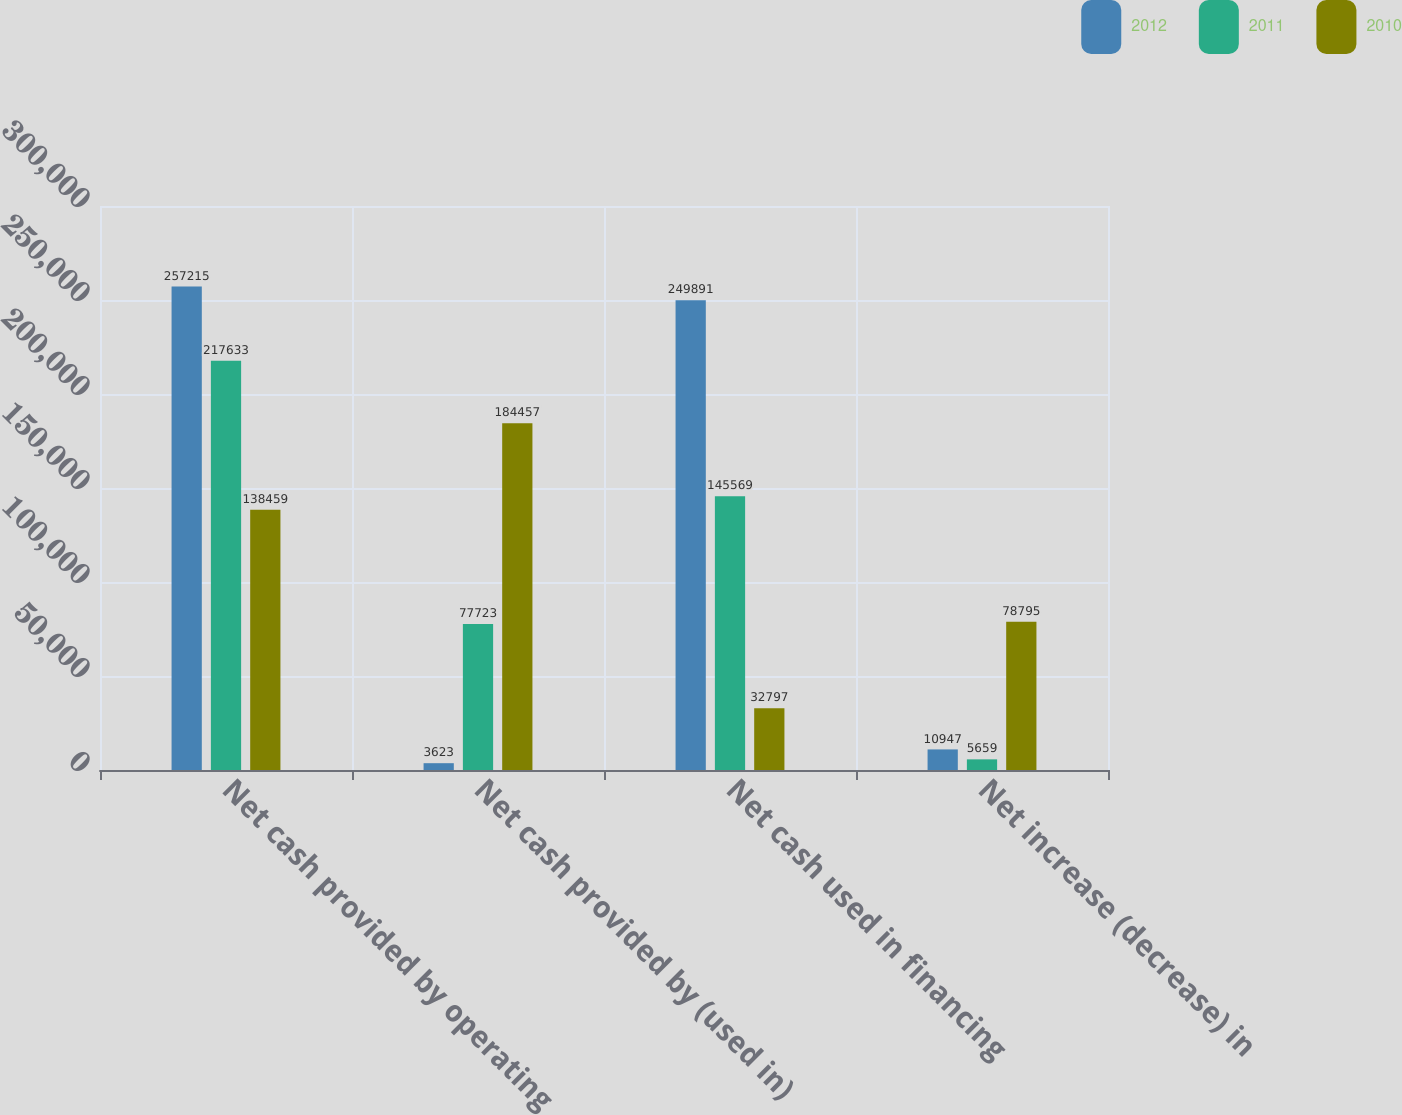Convert chart. <chart><loc_0><loc_0><loc_500><loc_500><stacked_bar_chart><ecel><fcel>Net cash provided by operating<fcel>Net cash provided by (used in)<fcel>Net cash used in financing<fcel>Net increase (decrease) in<nl><fcel>2012<fcel>257215<fcel>3623<fcel>249891<fcel>10947<nl><fcel>2011<fcel>217633<fcel>77723<fcel>145569<fcel>5659<nl><fcel>2010<fcel>138459<fcel>184457<fcel>32797<fcel>78795<nl></chart> 